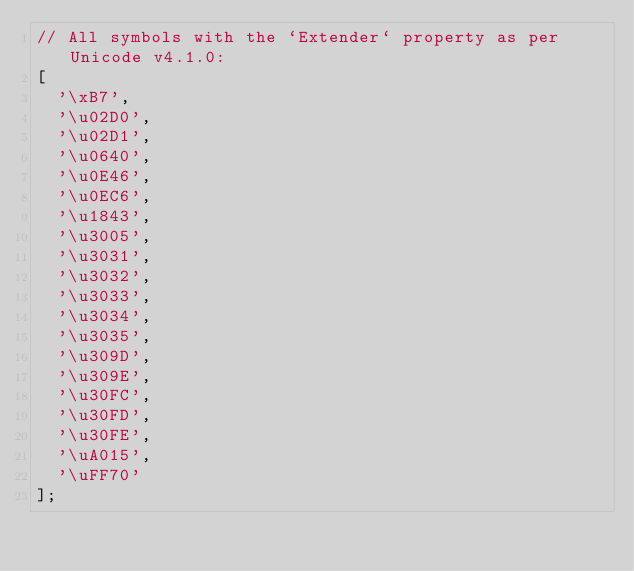<code> <loc_0><loc_0><loc_500><loc_500><_JavaScript_>// All symbols with the `Extender` property as per Unicode v4.1.0:
[
	'\xB7',
	'\u02D0',
	'\u02D1',
	'\u0640',
	'\u0E46',
	'\u0EC6',
	'\u1843',
	'\u3005',
	'\u3031',
	'\u3032',
	'\u3033',
	'\u3034',
	'\u3035',
	'\u309D',
	'\u309E',
	'\u30FC',
	'\u30FD',
	'\u30FE',
	'\uA015',
	'\uFF70'
];</code> 